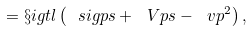Convert formula to latex. <formula><loc_0><loc_0><loc_500><loc_500>= \S i g t l \left ( \ s i g p s + \ V p s - \ v p ^ { 2 } \right ) ,</formula> 